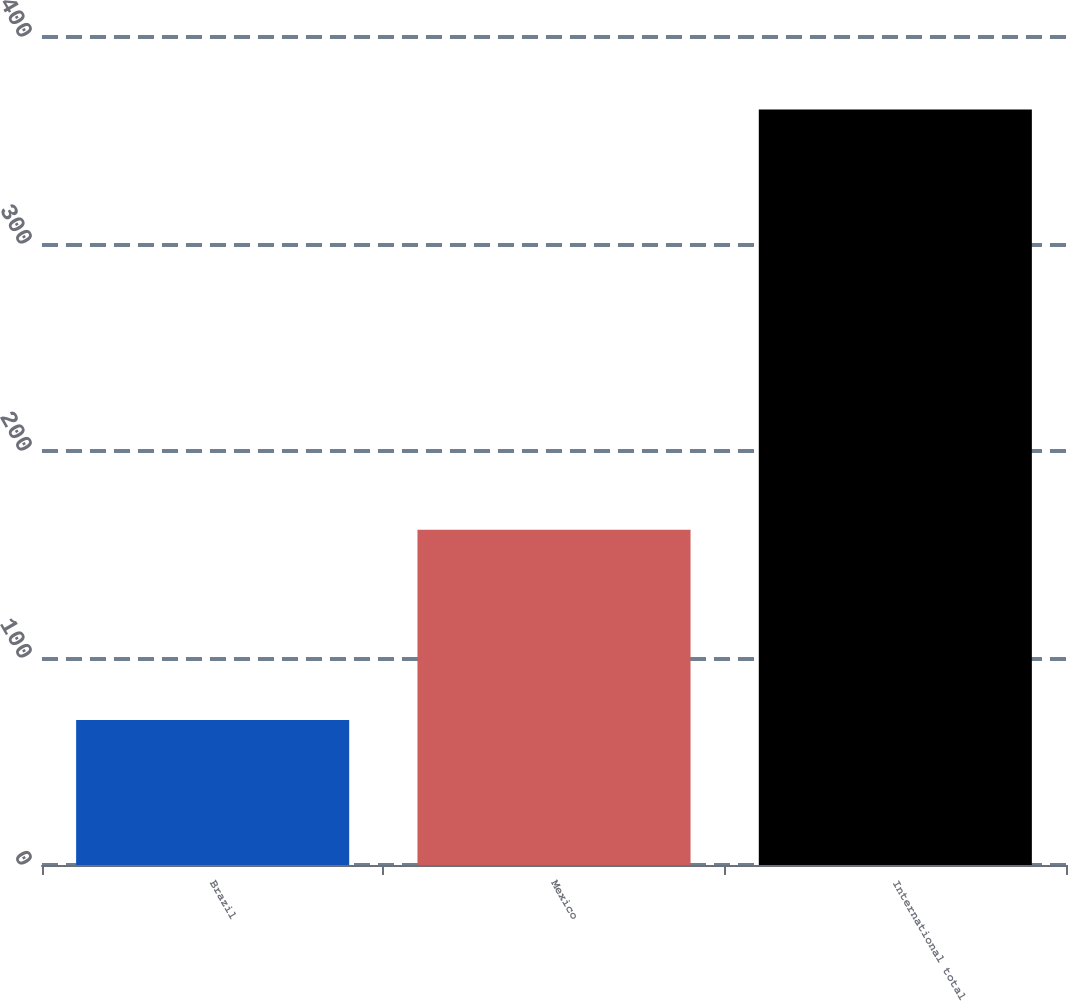<chart> <loc_0><loc_0><loc_500><loc_500><bar_chart><fcel>Brazil<fcel>Mexico<fcel>International total<nl><fcel>70<fcel>162<fcel>365<nl></chart> 